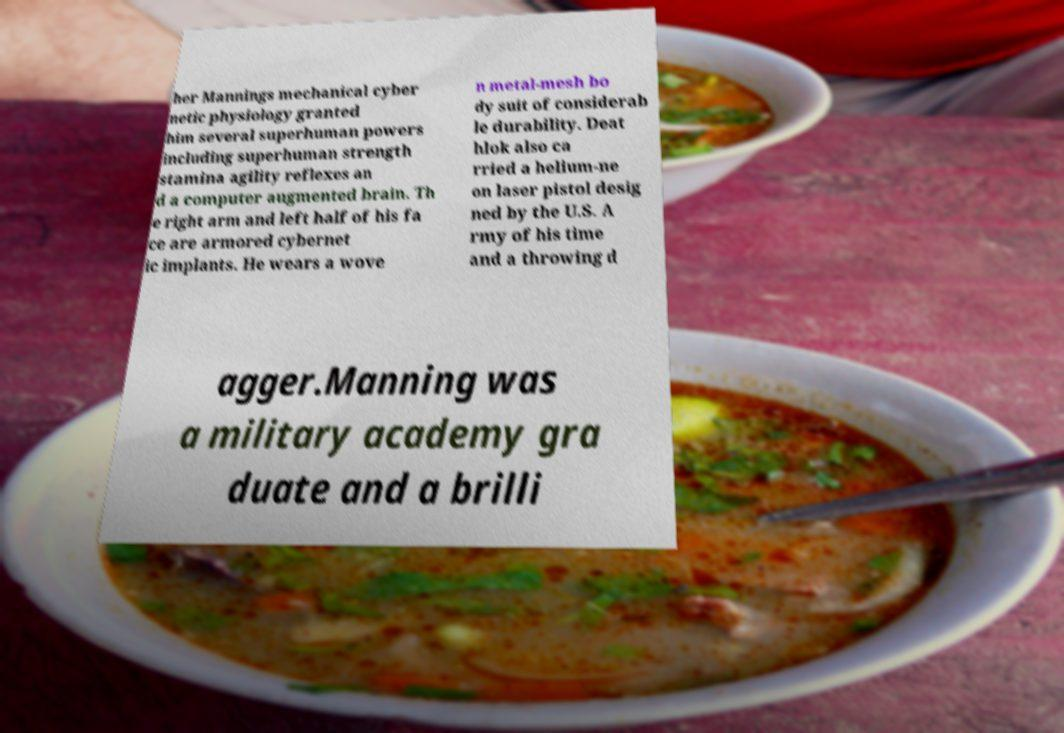Can you read and provide the text displayed in the image?This photo seems to have some interesting text. Can you extract and type it out for me? her Mannings mechanical cyber netic physiology granted him several superhuman powers including superhuman strength stamina agility reflexes an d a computer augmented brain. Th e right arm and left half of his fa ce are armored cybernet ic implants. He wears a wove n metal-mesh bo dy suit of considerab le durability. Deat hlok also ca rried a helium-ne on laser pistol desig ned by the U.S. A rmy of his time and a throwing d agger.Manning was a military academy gra duate and a brilli 